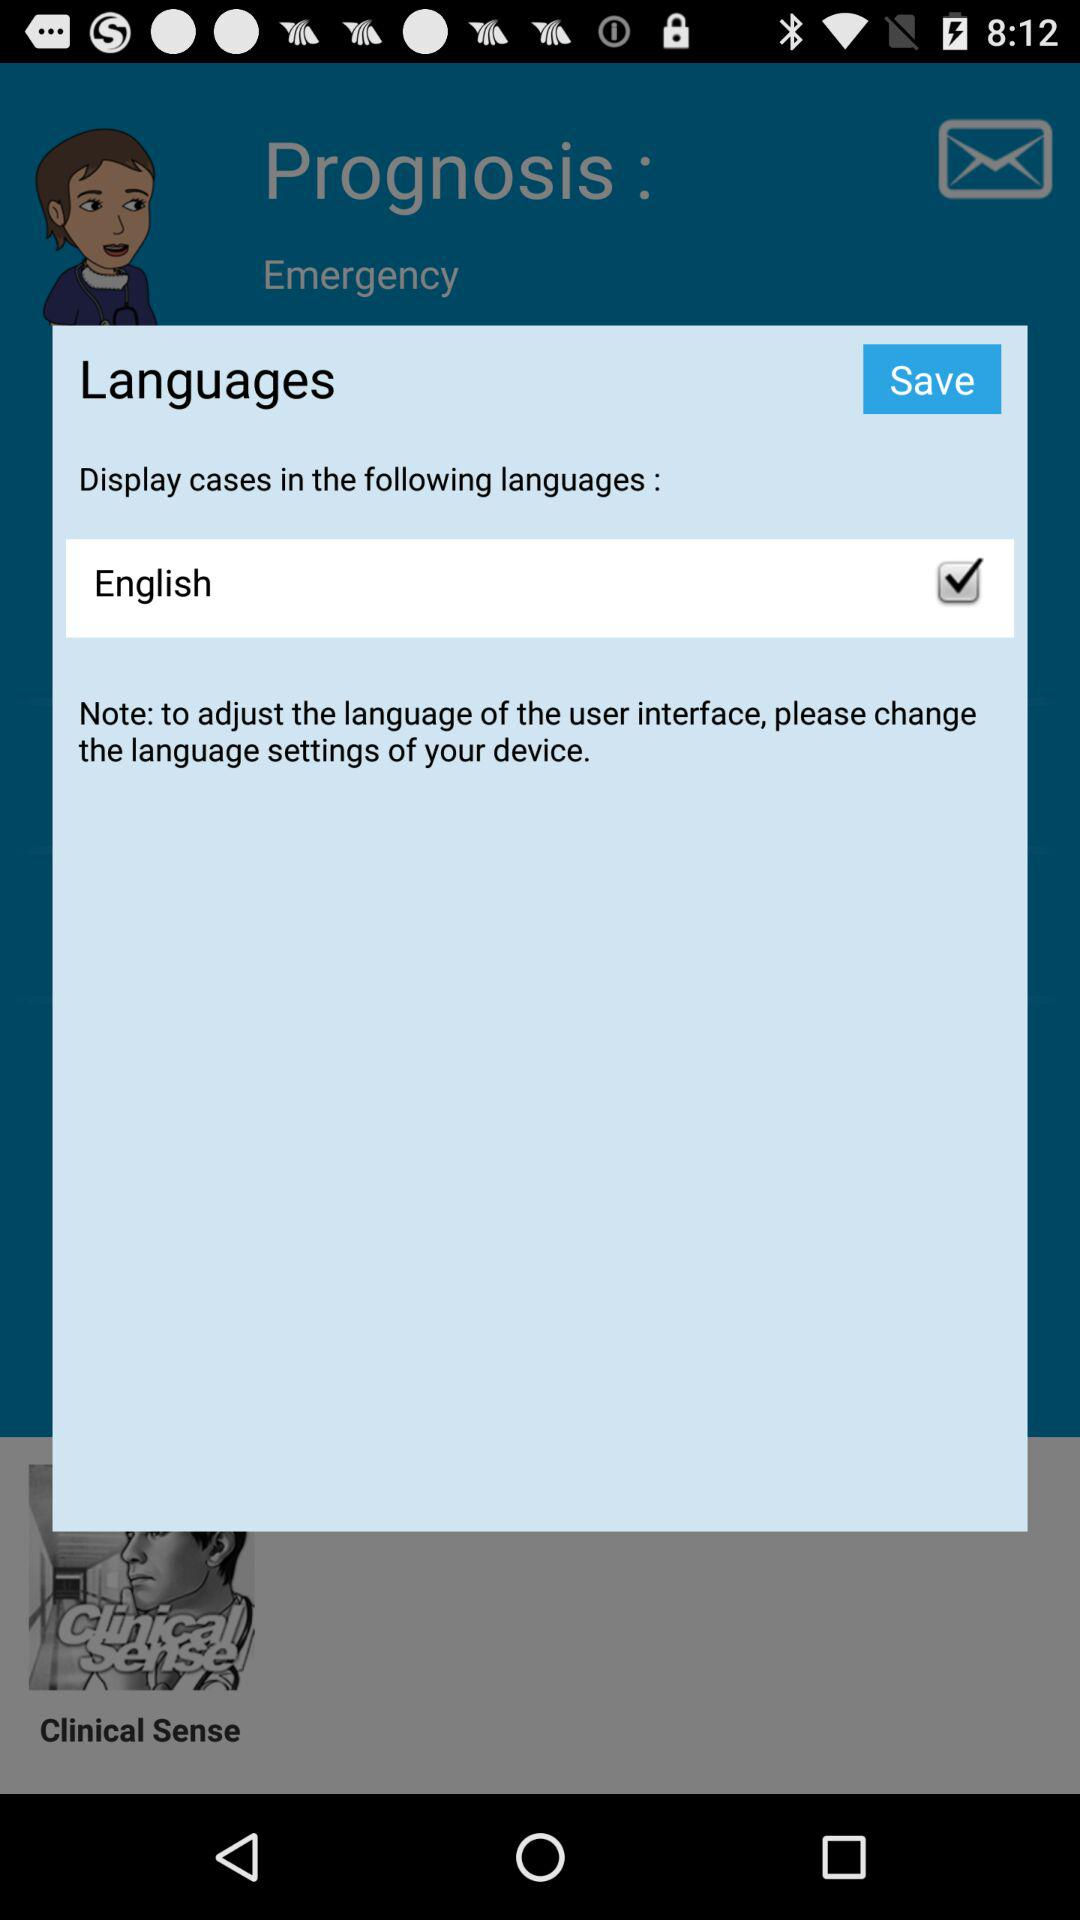What is the selected language? The selected language is English. 